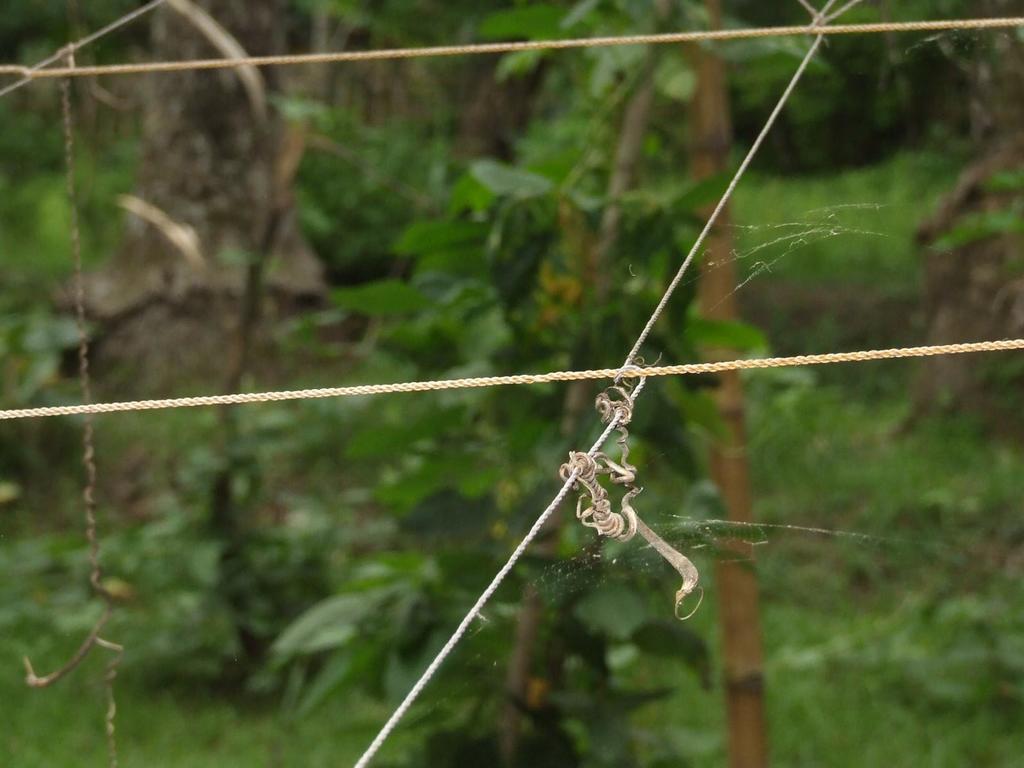How would you summarize this image in a sentence or two? In this image we can see ropes, creepers and spider webs. In the background of the image there are trees. 